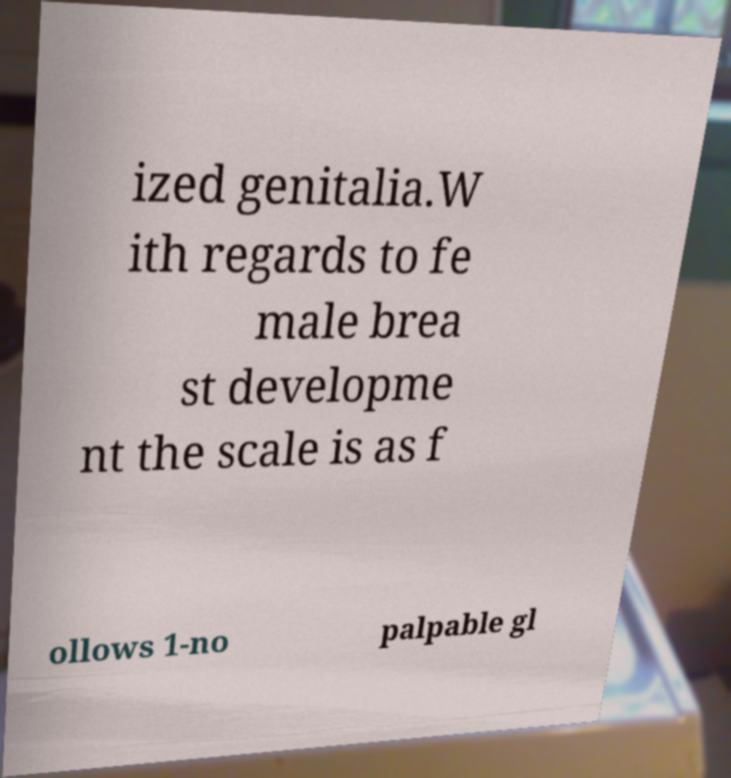Could you extract and type out the text from this image? ized genitalia.W ith regards to fe male brea st developme nt the scale is as f ollows 1-no palpable gl 